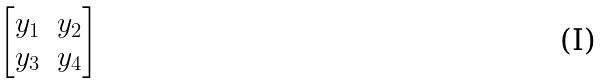Convert formula to latex. <formula><loc_0><loc_0><loc_500><loc_500>\begin{bmatrix} y _ { 1 } & y _ { 2 } \\ y _ { 3 } & y _ { 4 } \end{bmatrix}</formula> 